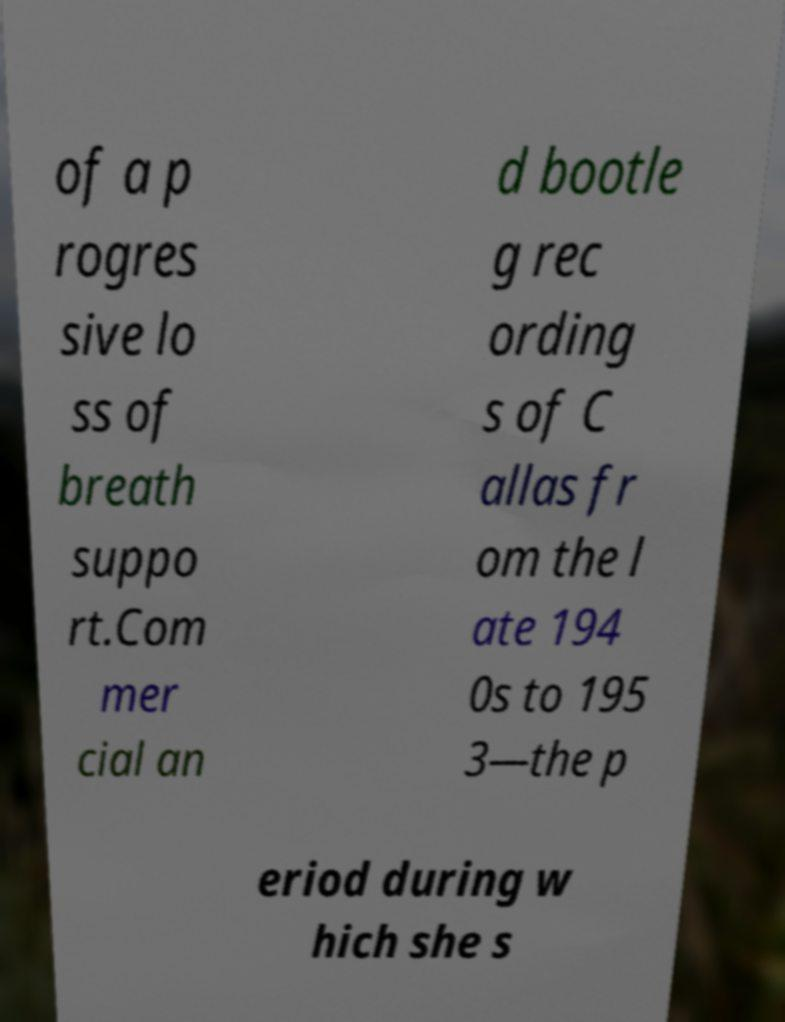Could you extract and type out the text from this image? of a p rogres sive lo ss of breath suppo rt.Com mer cial an d bootle g rec ording s of C allas fr om the l ate 194 0s to 195 3—the p eriod during w hich she s 